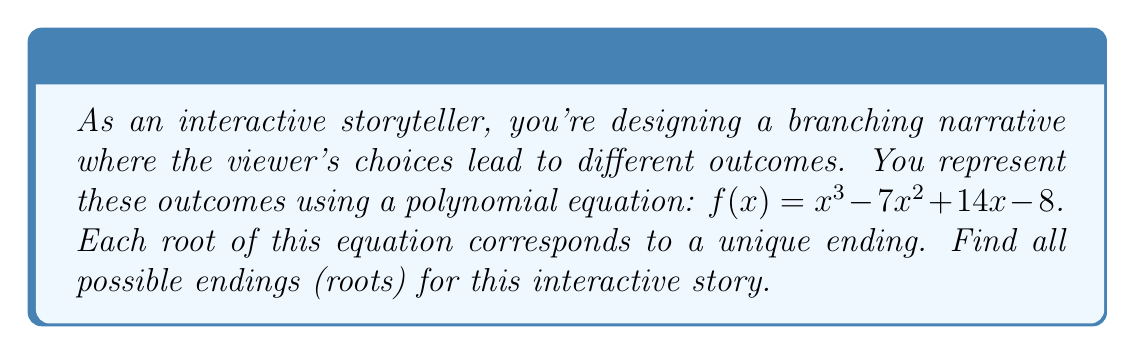Show me your answer to this math problem. To find the roots of the polynomial $f(x) = x^3 - 7x^2 + 14x - 8$, we'll use the rational root theorem and synthetic division.

Step 1: Identify potential rational roots
The potential rational roots are factors of the constant term (8):
$\pm 1, \pm 2, \pm 4, \pm 8$

Step 2: Test potential roots using synthetic division

Let's start with 1:
$$
\begin{array}{r}
1 \enclose{longdiv}{1 \quad -7 \quad 14 \quad -8} \\
\underline{1 \quad -6 \quad 8} \\
1 \quad -6 \quad 8 \quad 0
\end{array}
$$

We found a root: $x = 1$

Step 3: Factor out $(x - 1)$
$f(x) = (x - 1)(x^2 - 6x + 8)$

Step 4: Solve the quadratic equation $x^2 - 6x + 8 = 0$
Using the quadratic formula: $x = \frac{-b \pm \sqrt{b^2 - 4ac}}{2a}$

$x = \frac{6 \pm \sqrt{36 - 32}}{2} = \frac{6 \pm 2}{2}$

$x = 4$ or $x = 2$

Therefore, the roots are $x = 1, 2, 4$
Answer: $x = 1, 2, 4$ 